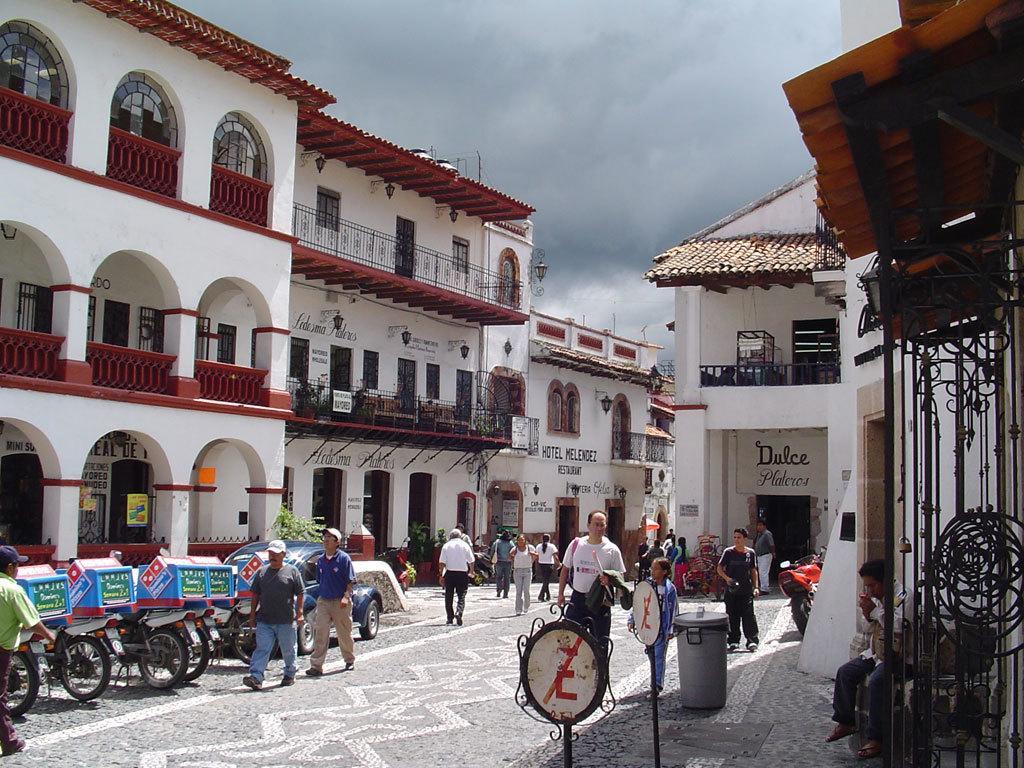Describe this image in one or two sentences. In the center of the image we can see a buildings, grills, bicycles, car and some persons are there. At the bottom of the image we can see a road, signboard, dustbin are present. At the top of the image clouds are present in the sky. 